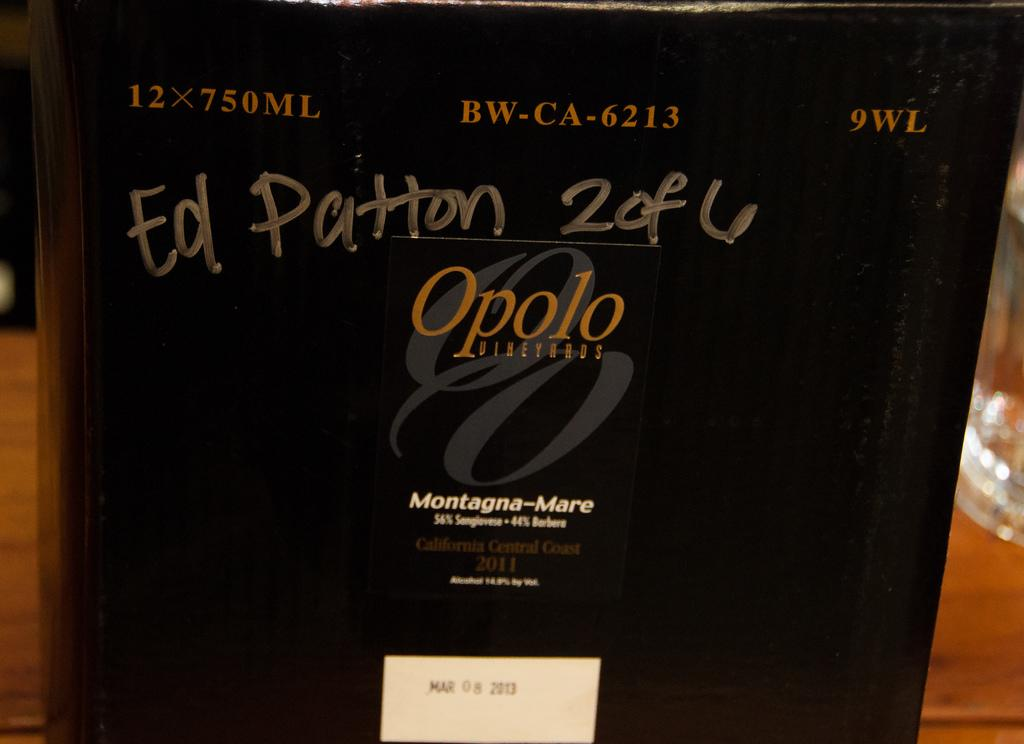<image>
Present a compact description of the photo's key features. Cover saying "Ed Patton" with the size 12x750mL. 